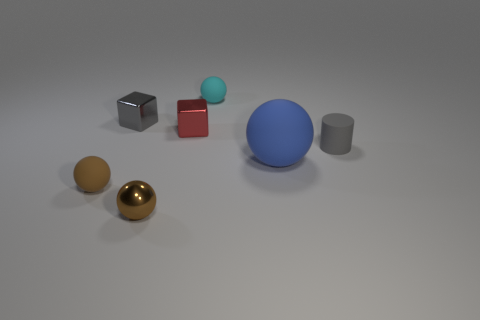Add 3 tiny gray metallic cylinders. How many objects exist? 10 Subtract all cylinders. How many objects are left? 6 Subtract 0 yellow balls. How many objects are left? 7 Subtract all big gray metallic things. Subtract all tiny cyan balls. How many objects are left? 6 Add 3 gray cubes. How many gray cubes are left? 4 Add 1 gray metal spheres. How many gray metal spheres exist? 1 